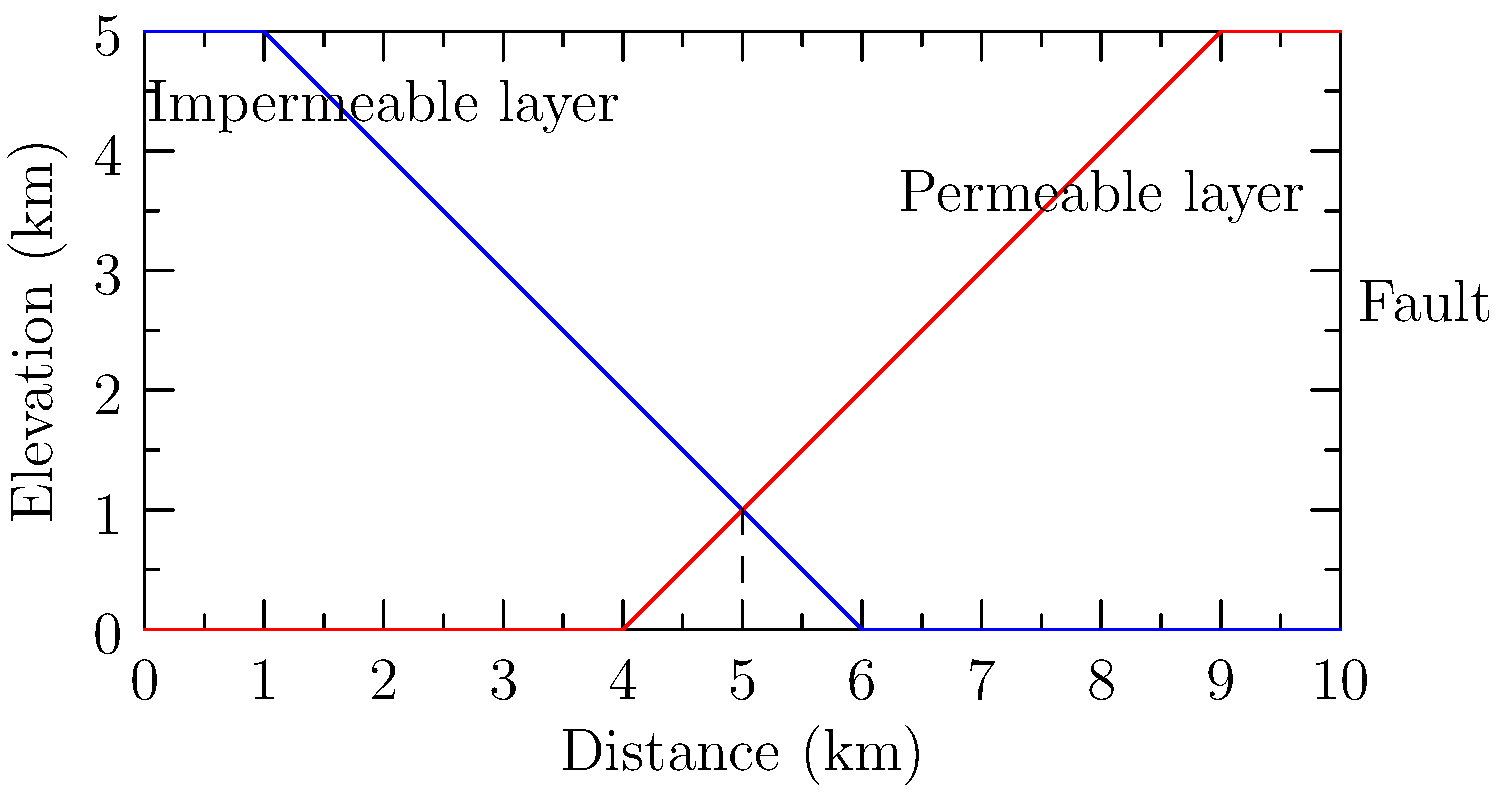Based on the geological cross-section provided, which of the following environmental impacts is most likely to occur if a hazardous waste disposal facility is constructed at the 3 km mark?

A) Groundwater contamination
B) Surface water pollution
C) Soil erosion
D) Air pollution To answer this question, we need to analyze the geological cross-section and understand the potential environmental impacts:

1. Identify the layers:
   - The blue line represents an impermeable layer (e.g., clay or bedrock).
   - The red line represents a permeable layer (e.g., sand or gravel).

2. Locate the proposed facility:
   - The hazardous waste disposal facility would be at the 3 km mark.

3. Analyze the geological structure:
   - At the 3 km mark, the impermeable layer is above the permeable layer.
   - There is a fault at the 5 km mark.

4. Consider potential environmental impacts:
   A) Groundwater contamination:
      - The impermeable layer above the permeable layer at the 3 km mark would protect groundwater from contamination.
   B) Surface water pollution:
      - The impermeable layer at the surface could lead to runoff, potentially causing surface water pollution.
   C) Soil erosion:
      - While possible, this is not the most significant concern given the geological structure.
   D) Air pollution:
      - This is not directly related to the geological structure shown.

5. Conclusion:
   The most likely environmental impact is surface water pollution (B) due to the impermeable layer at the surface, which could cause hazardous materials to run off rather than infiltrate into the ground.
Answer: B) Surface water pollution 